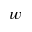Convert formula to latex. <formula><loc_0><loc_0><loc_500><loc_500>w</formula> 